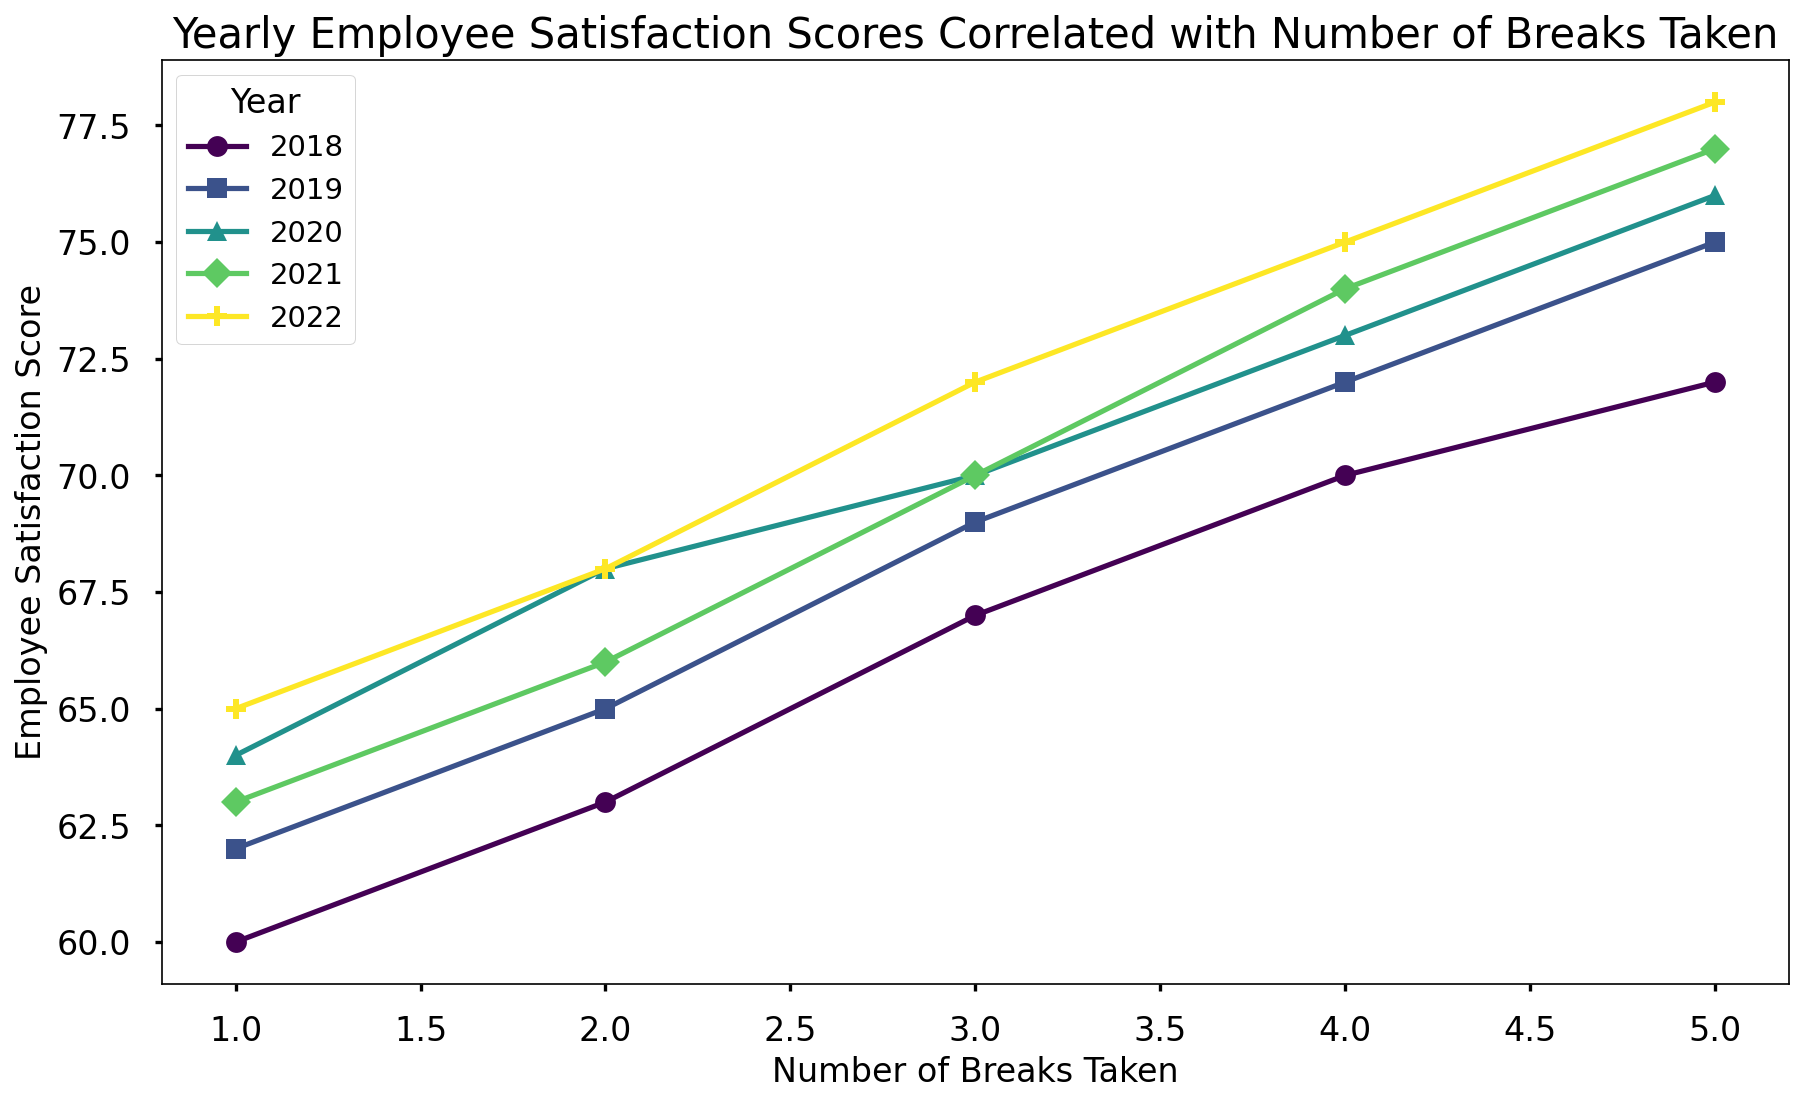What's the trend observed across all years in relation to the number of breaks taken and employee satisfaction scores? By examining the lines for each year, we notice an upward trend in employee satisfaction scores as the number of breaks taken increases. This trend is consistent across all the years presented in the figure.
Answer: Increasing breaks lead to higher satisfaction Which year shows the highest employee satisfaction score when 4 breaks are taken? We look at the employee satisfaction scores at 4 breaks for each year (2018, 2019, 2020, 2021, 2022) from the figure. We see that the year 2022 has the highest score at 75.
Answer: 2022 How do the scores differ between 2018 and 2020 when 3 breaks are taken? From the figure, we observe the employee satisfaction score for 3 breaks in 2018 is 67, whereas for 2020 it is 70. Calculating the difference, we get 70 - 67 = 3.
Answer: 3 Which year had the most consistent increase in employee satisfaction scores with the increase in the number of breaks? By visually comparing the lines for each year, the year 2022 shows the most consistent and steady increase in employee satisfaction scores as the number of breaks increases consistently from 65 to 78.
Answer: 2022 At which number of breaks does the employee satisfaction score start to diverge the most noticeably between different years? By examining the figure, we see that the points start diverging the most around 3 to 4 breaks, where differences in scores between years such as 2018, 2020, and 2022 become more pronounced.
Answer: 3 to 4 breaks If an employee is aiming for a satisfaction score of at least 72, how many breaks should they take according to 2020 data? Looking at the 2020 line in the figure, to achieve a satisfaction score of at least 72, the employee should take at least 4 breaks.
Answer: 4 breaks By how much does the employee satisfaction score improve from taking 1 break to 5 breaks in the year 2019? The satisfaction score at 1 break in 2019 is 62 and at 5 breaks is 75. So, the improvement is calculated as 75 - 62 = 13.
Answer: 13 Which year showed the least improvement in employee satisfaction score as the number of breaks increased from 1 to 5? To find this, we look at the difference in scores at 1 break and 5 breaks for each year. The year 2021 shows the least improvement with a change from 63 to 77, resulting in a difference of 77 - 63 = 14.
Answer: 2021 Comparing the years 2018 and 2021, how do the trends in employee satisfaction scores differ for the number of breaks taken? Observing the figure, in 2018, the satisfaction score increases relatively steadily from 60 to 72, while in 2021, the increase is also steady from 63 to 77 but starts higher and ends higher, showing a larger range of improvement.
Answer: 2018: Steady increase from 60 to 72; 2021: Steady increase from 63 to 77 What is the average employee satisfaction score across all years when 2 breaks are taken? We find the scores for 2 breaks in each year: 2018 (63), 2019 (65), 2020 (68), 2021 (66), and 2022 (68). Then, sum them up (63 + 65 + 68 + 66 + 68 = 330) and divide by 5 (330/5).
Answer: 66 